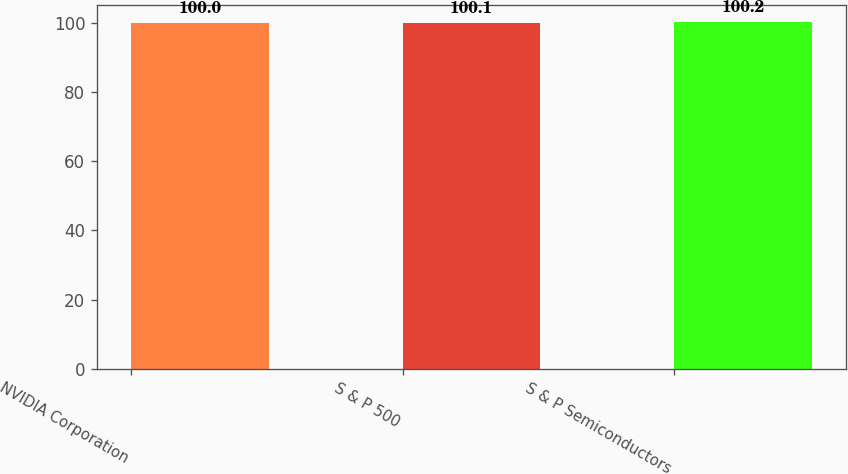<chart> <loc_0><loc_0><loc_500><loc_500><bar_chart><fcel>NVIDIA Corporation<fcel>S & P 500<fcel>S & P Semiconductors<nl><fcel>100<fcel>100.1<fcel>100.2<nl></chart> 